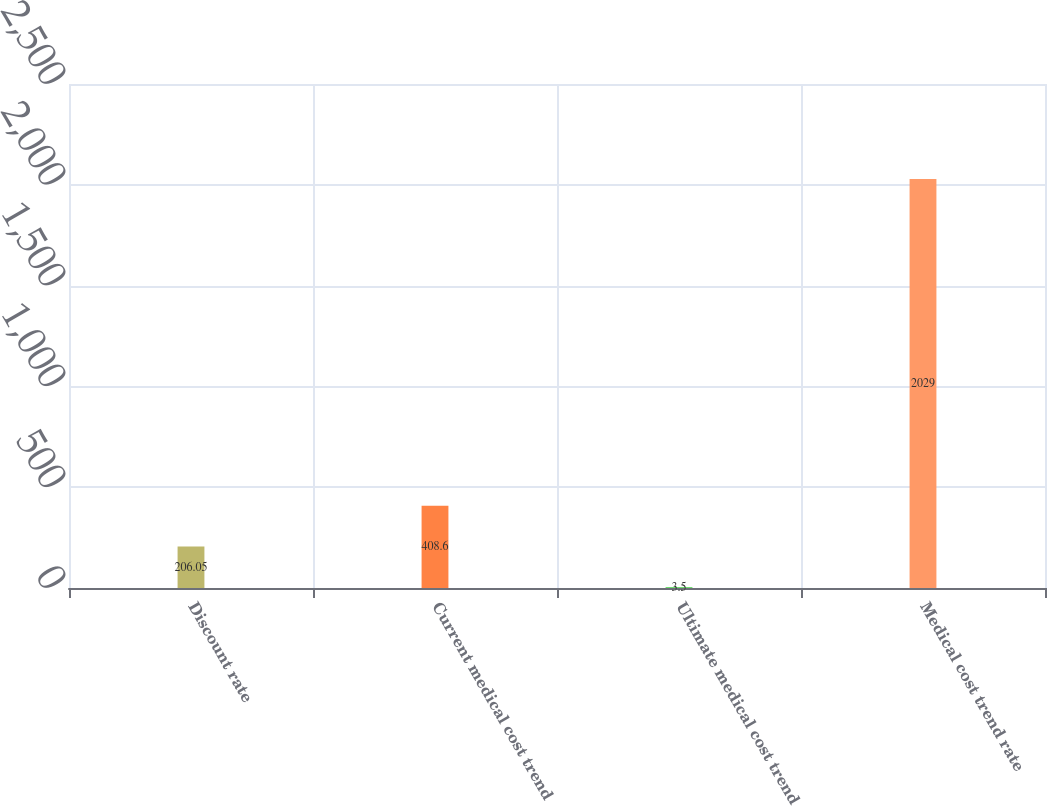Convert chart. <chart><loc_0><loc_0><loc_500><loc_500><bar_chart><fcel>Discount rate<fcel>Current medical cost trend<fcel>Ultimate medical cost trend<fcel>Medical cost trend rate<nl><fcel>206.05<fcel>408.6<fcel>3.5<fcel>2029<nl></chart> 